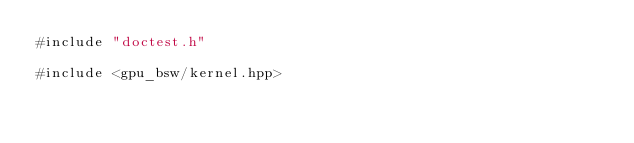Convert code to text. <code><loc_0><loc_0><loc_500><loc_500><_Cuda_>#include "doctest.h"

#include <gpu_bsw/kernel.hpp>
</code> 